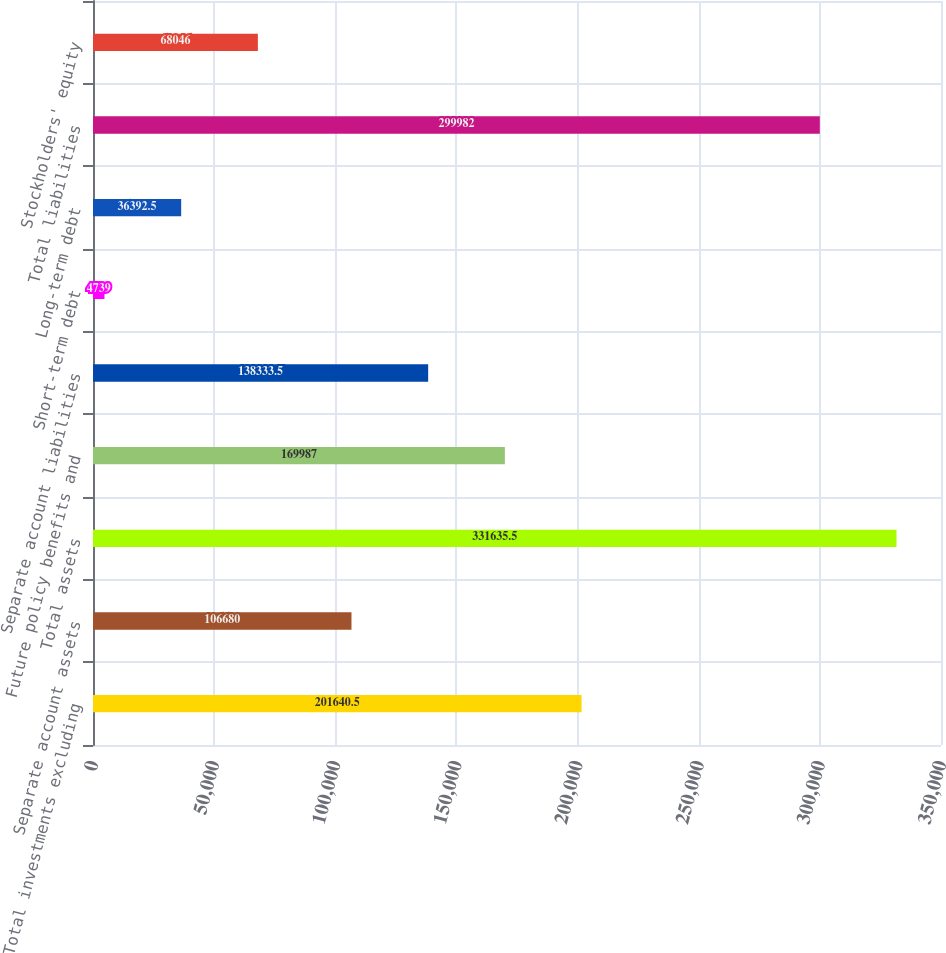Convert chart to OTSL. <chart><loc_0><loc_0><loc_500><loc_500><bar_chart><fcel>Total investments excluding<fcel>Separate account assets<fcel>Total assets<fcel>Future policy benefits and<fcel>Separate account liabilities<fcel>Short-term debt<fcel>Long-term debt<fcel>Total liabilities<fcel>Stockholders' equity<nl><fcel>201640<fcel>106680<fcel>331636<fcel>169987<fcel>138334<fcel>4739<fcel>36392.5<fcel>299982<fcel>68046<nl></chart> 